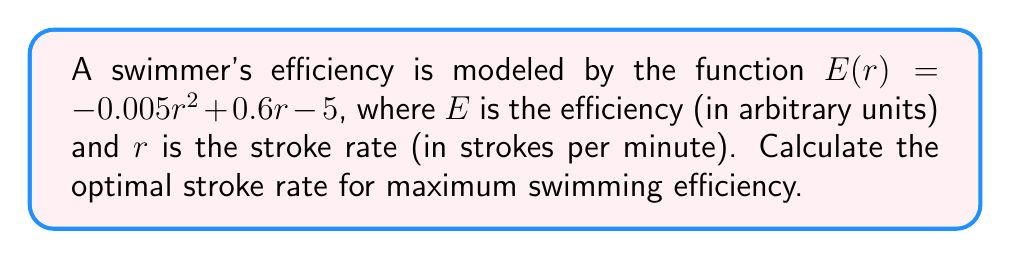Solve this math problem. To find the optimal stroke rate for maximum efficiency, we need to find the maximum point of the given quadratic function. This can be done by following these steps:

1) The function $E(r) = -0.005r^2 + 0.6r - 5$ is a quadratic function in the form $ar^2 + br + c$, where:
   $a = -0.005$
   $b = 0.6$
   $c = -5$

2) For a quadratic function, the maximum (or minimum) occurs at the vertex. The r-coordinate of the vertex can be found using the formula:

   $r = -\frac{b}{2a}$

3) Substituting our values:

   $r = -\frac{0.6}{2(-0.005)} = -\frac{0.6}{-0.01} = 60$

4) To verify this is a maximum (not a minimum), we can check that $a < 0$, which it is in this case.

5) Therefore, the optimal stroke rate for maximum efficiency is 60 strokes per minute.
Answer: 60 strokes per minute 